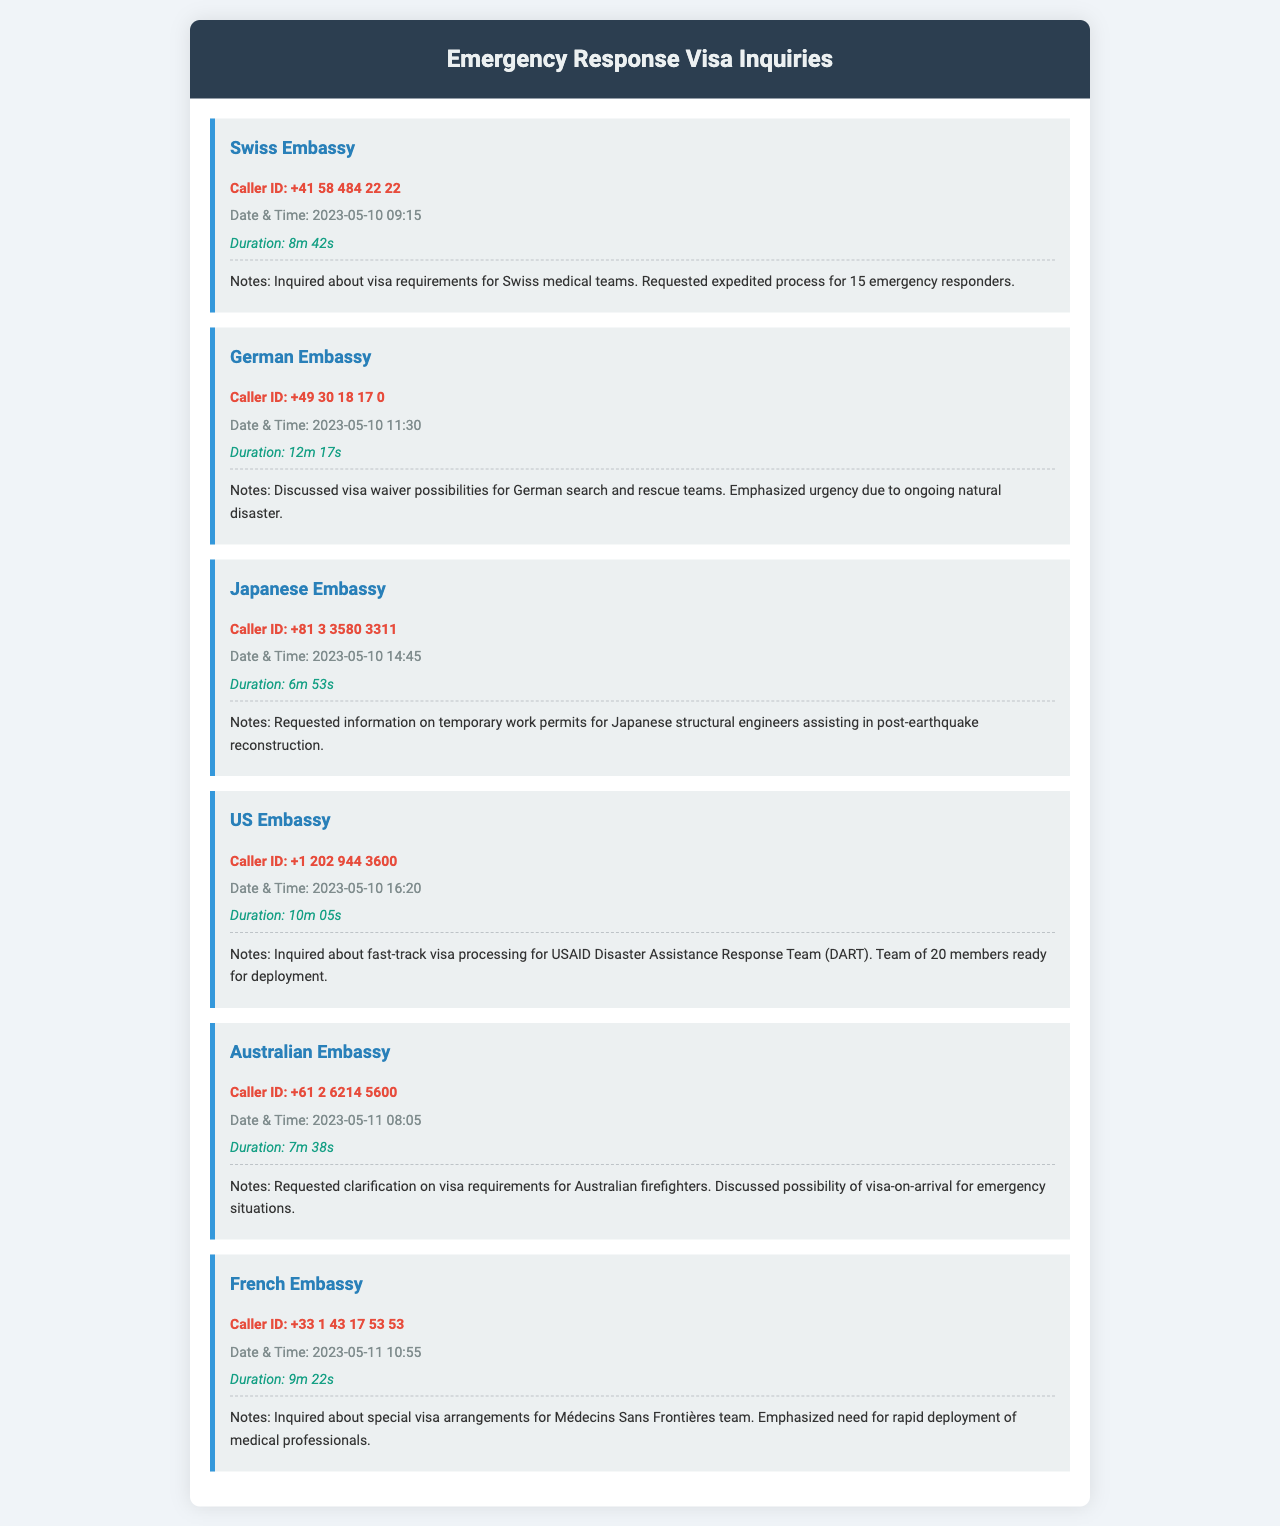what is the caller ID for the Swiss Embassy? The caller ID for the Swiss Embassy is listed in their record.
Answer: +41 58 484 22 22 what was the duration of the call from the German Embassy? The duration of the call is specified in the record for the German Embassy.
Answer: 12m 17s how many emergency responders were mentioned in the Swiss Embassy's notes? The number of emergency responders is clearly mentioned in the notes for the Swiss Embassy.
Answer: 15 which embassy inquired about fast-track visa processing? The embassy that inquired about fast-track visa processing is detailed in one of the records.
Answer: US Embassy what was the date and time of the call from the Australian Embassy? The date and time are recorded in the Australian Embassy's entry.
Answer: 2023-05-11 08:05 which country’s embassy requested information on temporary work permits? The embassy requesting information on temporary work permits is identified in their notes.
Answer: Japanese Embassy who emphasized the need for rapid deployment of medical professionals? The entity that emphasized the need for rapid deployment is noted in the French Embassy's record.
Answer: Médecins Sans Frontières team what is the main purpose of the call from the US Embassy? The main purpose of the call is described in the notes for the US Embassy.
Answer: Fast-track visa processing 